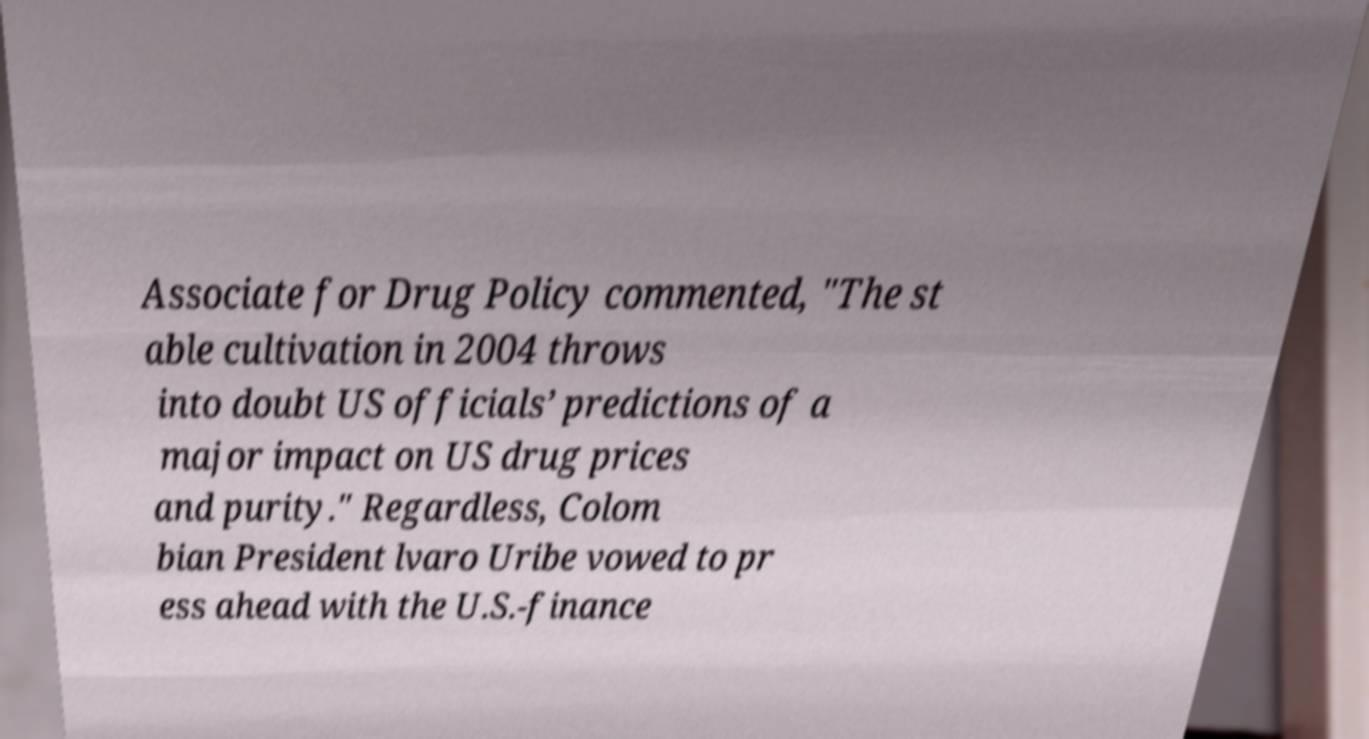Can you accurately transcribe the text from the provided image for me? Associate for Drug Policy commented, "The st able cultivation in 2004 throws into doubt US officials’ predictions of a major impact on US drug prices and purity." Regardless, Colom bian President lvaro Uribe vowed to pr ess ahead with the U.S.-finance 